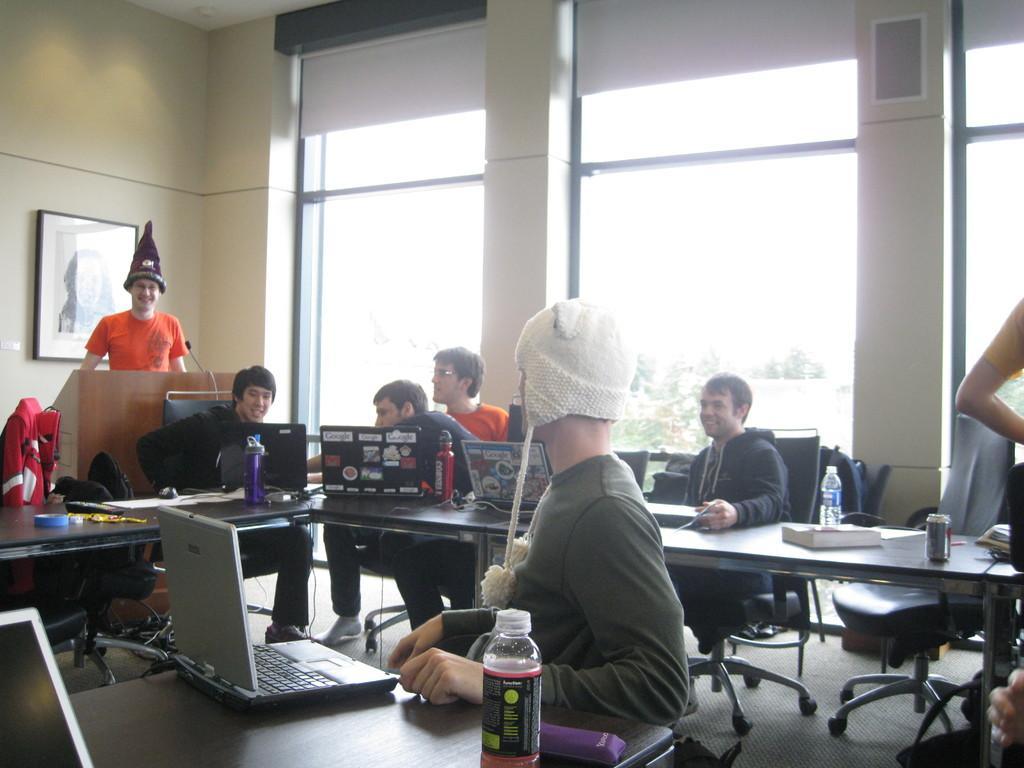Please provide a concise description of this image. In this picture we can see a group of men sitting on chairs and they are smiling and in front of them on table we have bottle, laptops, tape, papers, book, tin, wires and in background we can see wall, frame, windows, pipe, pillar. 